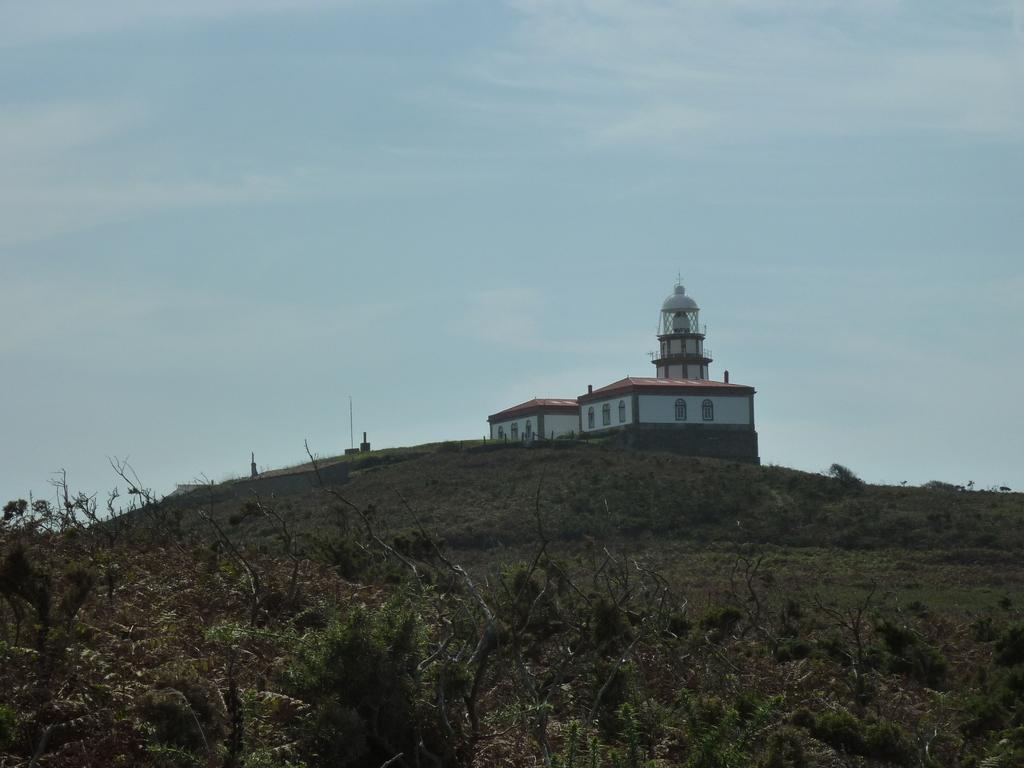What is the main subject of the image? The main subject of the image is a building on top of a mountain. What can be seen in the background of the image? There is a group of plants and the sky visible in the background of the image. What type of shirt is the scarecrow wearing in the image? There is no scarecrow present in the image, so it is not possible to determine what type of shirt it might be wearing. 